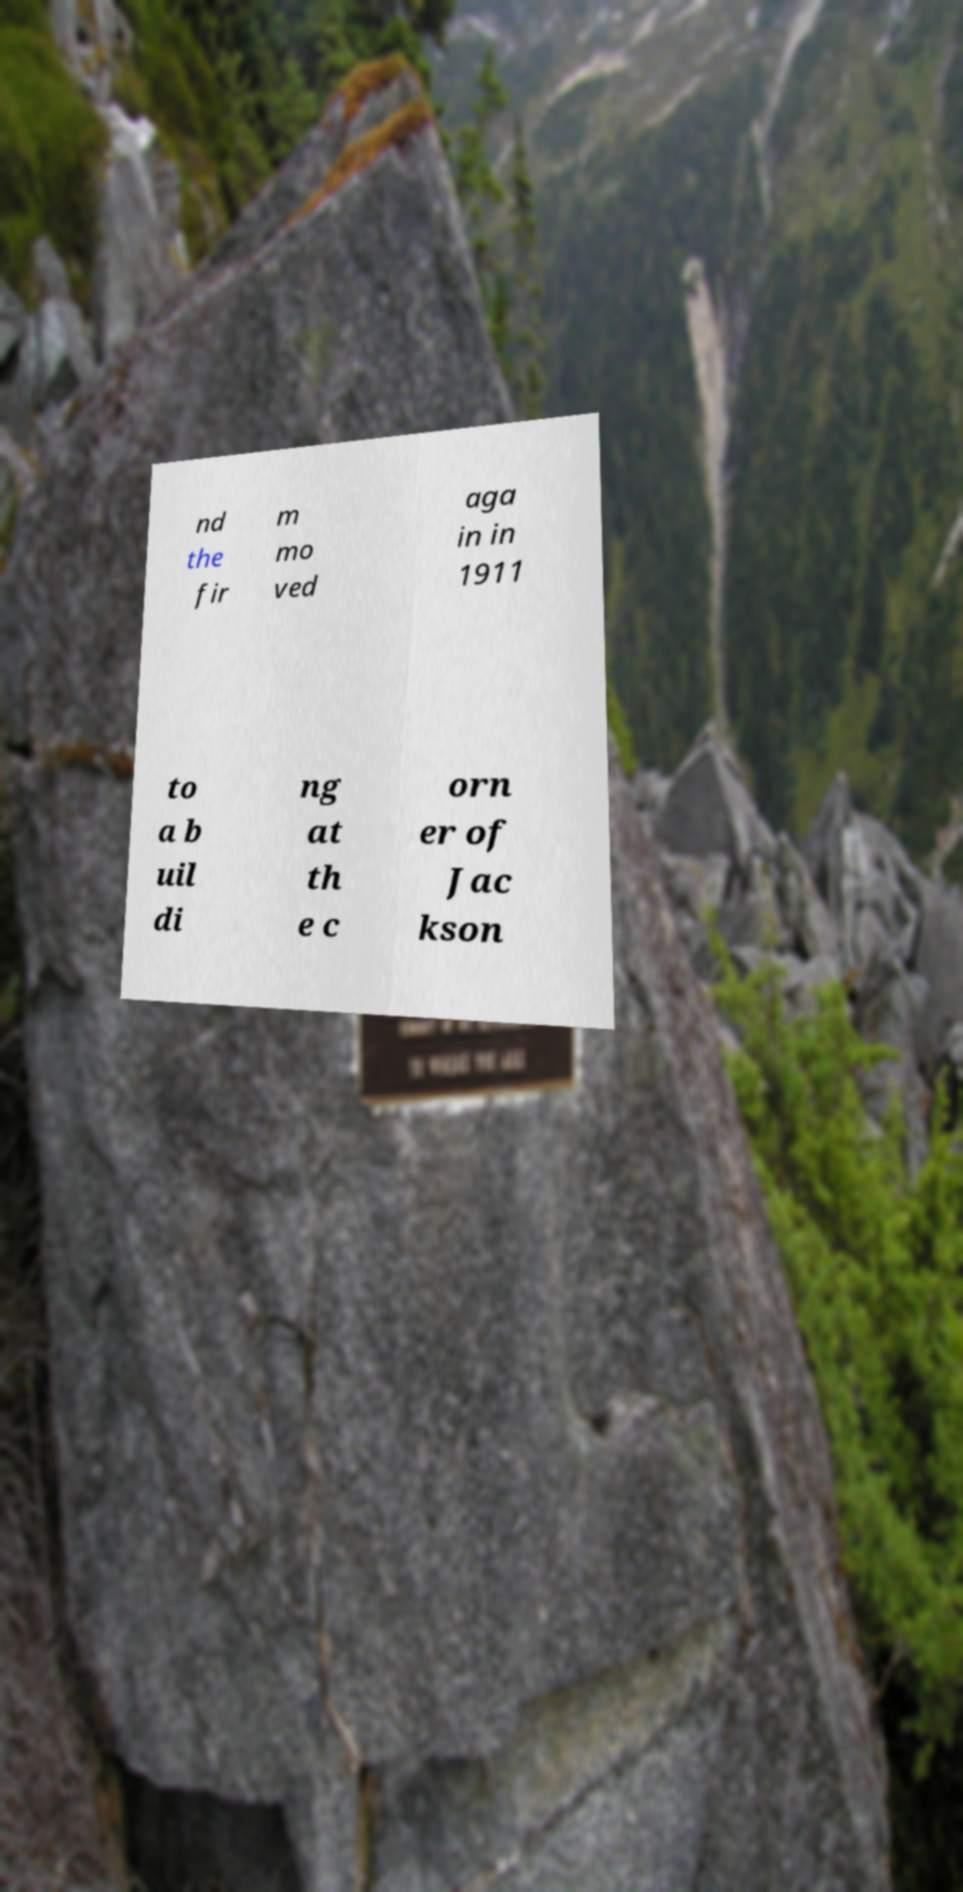For documentation purposes, I need the text within this image transcribed. Could you provide that? nd the fir m mo ved aga in in 1911 to a b uil di ng at th e c orn er of Jac kson 